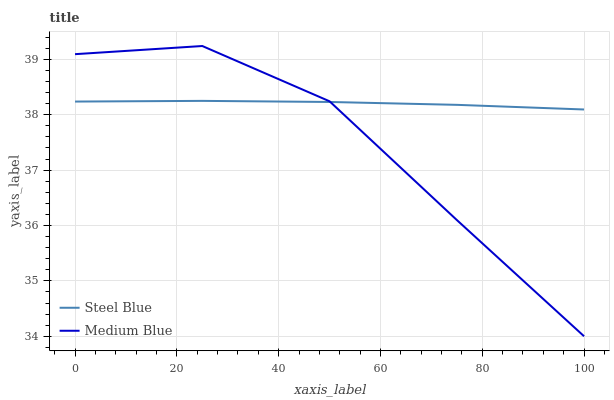Does Steel Blue have the minimum area under the curve?
Answer yes or no. No. Is Steel Blue the roughest?
Answer yes or no. No. Does Steel Blue have the lowest value?
Answer yes or no. No. Does Steel Blue have the highest value?
Answer yes or no. No. 